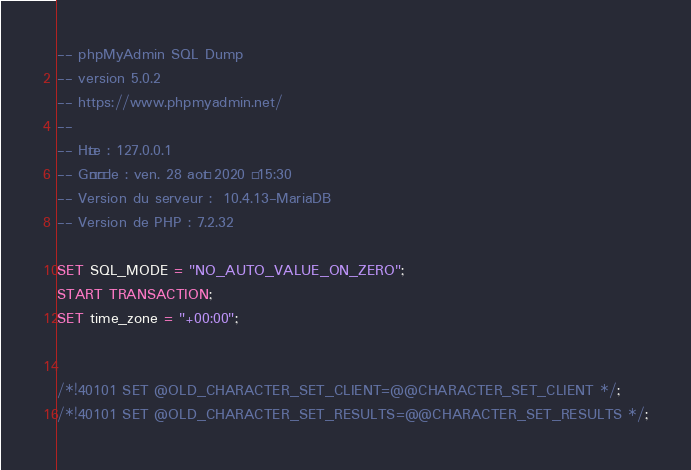Convert code to text. <code><loc_0><loc_0><loc_500><loc_500><_SQL_>-- phpMyAdmin SQL Dump
-- version 5.0.2
-- https://www.phpmyadmin.net/
--
-- Hôte : 127.0.0.1
-- Généré le : ven. 28 août 2020 à 15:30
-- Version du serveur :  10.4.13-MariaDB
-- Version de PHP : 7.2.32

SET SQL_MODE = "NO_AUTO_VALUE_ON_ZERO";
START TRANSACTION;
SET time_zone = "+00:00";


/*!40101 SET @OLD_CHARACTER_SET_CLIENT=@@CHARACTER_SET_CLIENT */;
/*!40101 SET @OLD_CHARACTER_SET_RESULTS=@@CHARACTER_SET_RESULTS */;</code> 